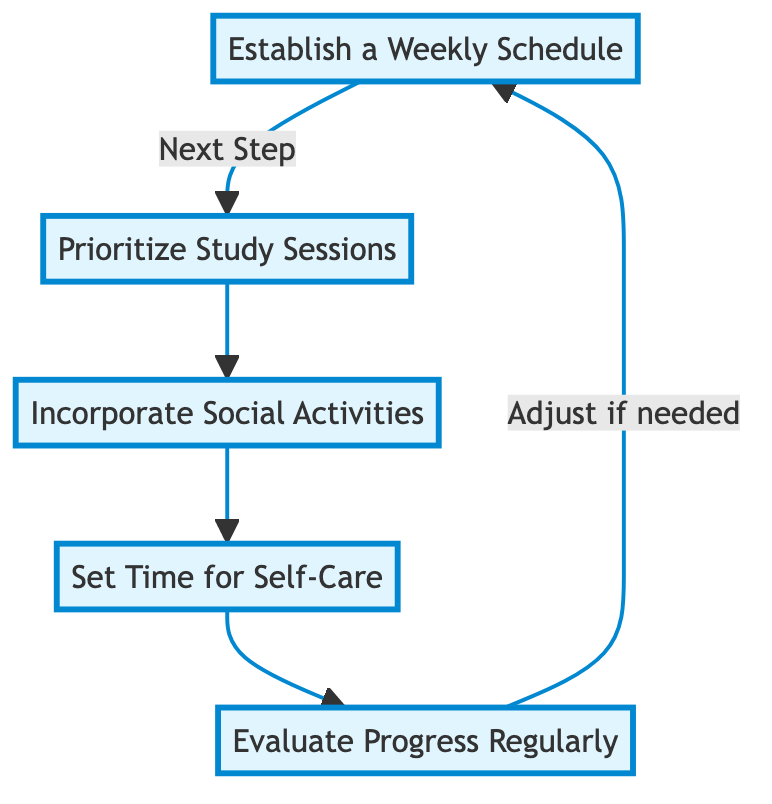What is the first step in the flow chart? The first step in the flow chart is represented by the node labeled "Establish a Weekly Schedule." This is the initial action that sets the foundation for the following steps.
Answer: Establish a Weekly Schedule What follows after "Prioritize Study Sessions"? After the "Prioritize Study Sessions," the next step is "Incorporate Social Activities." This means after you prioritize studying, the flow leads to planning social activities.
Answer: Incorporate Social Activities How many main components are in the flow chart? The flow chart includes five main components, each representing a critical part of planning a balanced lifestyle. These components are interconnected in sequence.
Answer: Five What step comes before "Set Time for Self-Care"? The step that comes before "Set Time for Self-Care" is "Incorporate Social Activities." This indicates the flow progresses from socializing to focusing on self-care.
Answer: Incorporate Social Activities If you need to "Evaluate Progress Regularly," what should you do next? After evaluating progress regularly, the chart indicates that you may need to "Adjust if needed," which suggests improvements or changes may be required based on the evaluation.
Answer: Adjust if needed What is the relationship between "Establish a Weekly Schedule" and "Evaluate Progress Regularly"? The relationship is cyclic. "Establish a Weekly Schedule" is the first step, and after evaluating progress, it loops back to this step, indicating ongoing refinement of the schedule based on evaluations.
Answer: Cyclic Which activity is highlighted as the last step in the flow chart? The last step highlighted in the flow chart is "Evaluate Progress Regularly." This is essential as it ensures continuous assessment of the balance between studies, social life, and self-care.
Answer: Evaluate Progress Regularly What is the primary purpose of the diagram? The primary purpose of the diagram is to illustrate a balanced lifestyle through effective time management across studies, social life, and self-care. It guides individuals to plan and assess their activities methodically.
Answer: Balanced lifestyle planning 